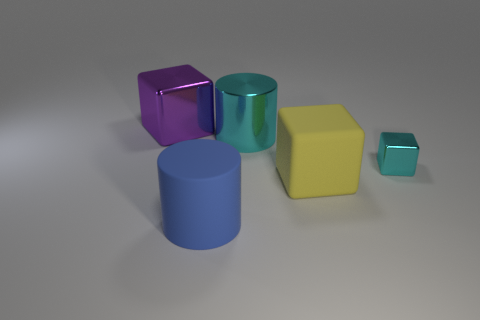What is the size of the thing that is the same color as the tiny block?
Ensure brevity in your answer.  Large. Is there anything else that has the same size as the purple block?
Offer a very short reply. Yes. Is the shape of the large cyan metal thing the same as the large yellow matte thing?
Provide a short and direct response. No. How big is the thing left of the big matte thing that is in front of the yellow rubber block?
Offer a very short reply. Large. What color is the other shiny thing that is the same shape as the tiny cyan thing?
Keep it short and to the point. Purple. What number of small metal cylinders are the same color as the small metal thing?
Provide a short and direct response. 0. What is the size of the cyan metal cylinder?
Your answer should be compact. Large. Is the cyan metallic cylinder the same size as the cyan block?
Give a very brief answer. No. What color is the big thing that is both in front of the tiny cyan shiny cube and on the left side of the big yellow matte cube?
Ensure brevity in your answer.  Blue. How many large things are the same material as the cyan cube?
Give a very brief answer. 2. 